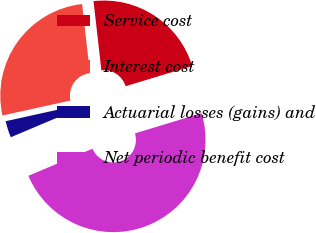Convert chart to OTSL. <chart><loc_0><loc_0><loc_500><loc_500><pie_chart><fcel>Service cost<fcel>Interest cost<fcel>Actuarial losses (gains) and<fcel>Net periodic benefit cost<nl><fcel>22.12%<fcel>26.66%<fcel>2.91%<fcel>48.31%<nl></chart> 